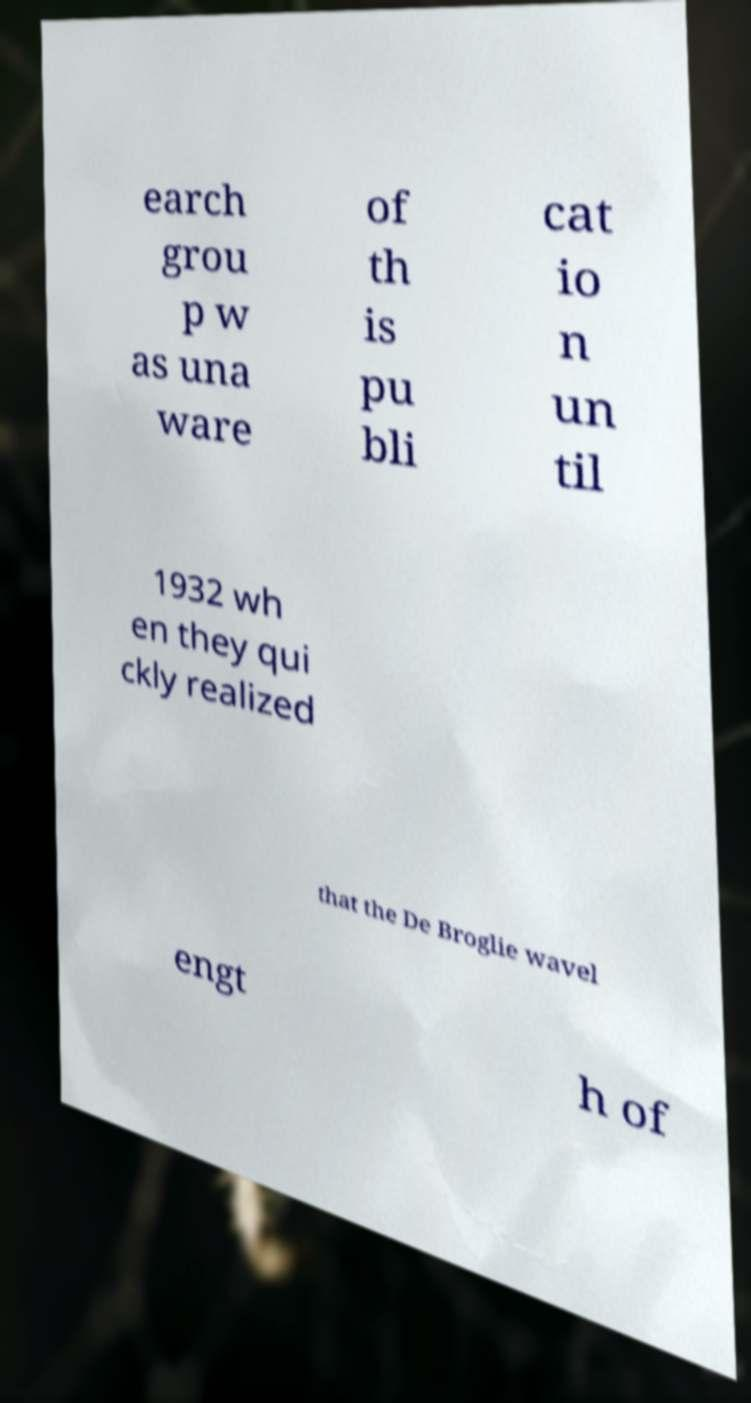Can you read and provide the text displayed in the image?This photo seems to have some interesting text. Can you extract and type it out for me? earch grou p w as una ware of th is pu bli cat io n un til 1932 wh en they qui ckly realized that the De Broglie wavel engt h of 